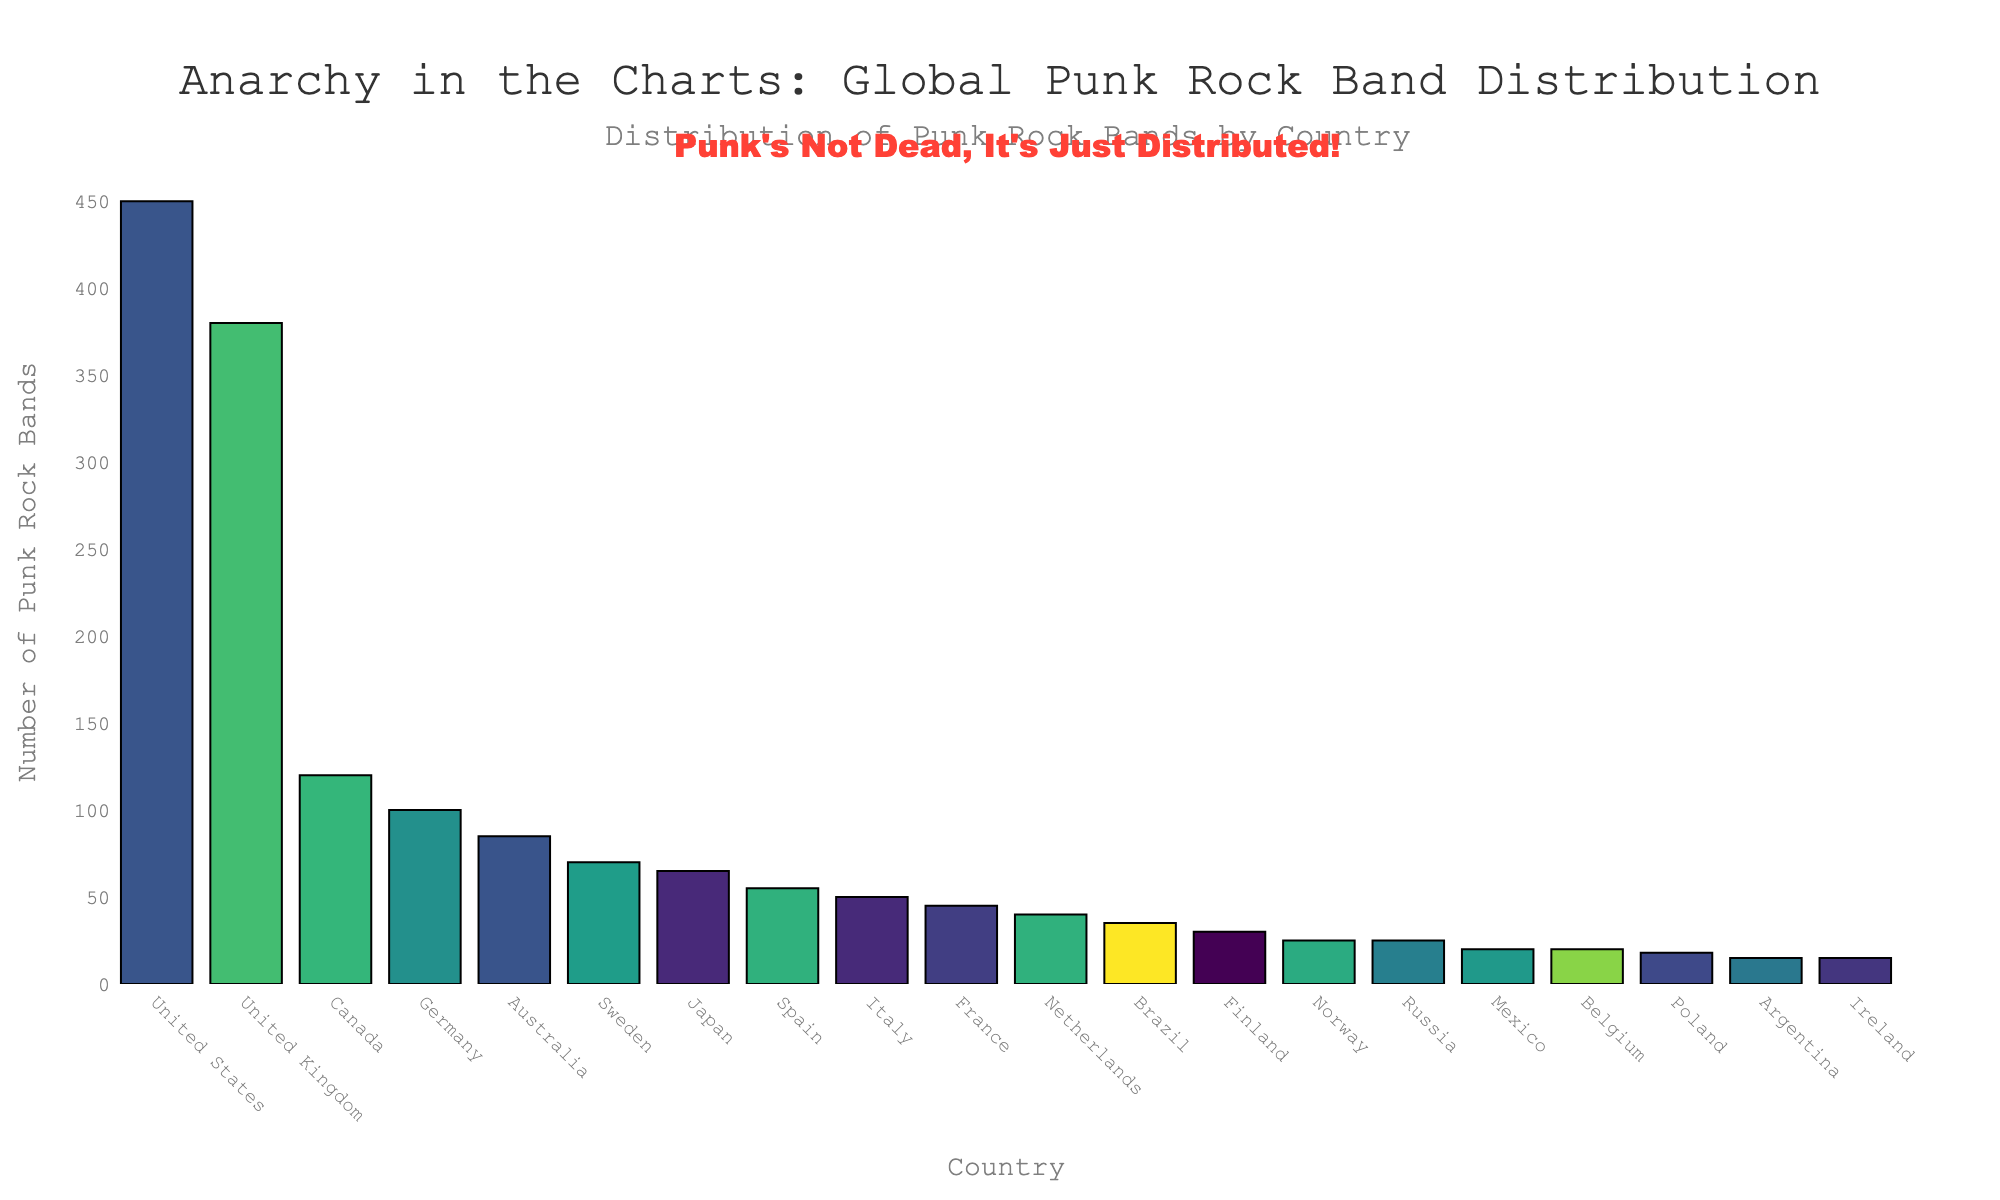What's the total number of punk rock bands from the top three countries? Add the number of bands from the United States, United Kingdom, and Canada (450 + 380 + 120).
Answer: 950 Which country has the second highest number of punk rock bands? Identify the second tallest bar in the chart, which corresponds to the United Kingdom.
Answer: United Kingdom How many more punk rock bands are there in Australia compared to Japan? Subtract the number of bands in Japan from the number in Australia (85 - 65).
Answer: 20 What is the average number of punk rock bands in Germany, Australia, and Sweden? Sum the number of bands from Germany, Australia, and Sweden, then divide by 3 ((100 + 85 + 70) / 3).
Answer: 85 Which countries have an equal number of punk rock bands, according to the data? Identify bars of the same height, Norway and Russia (both with 25 bands), and Mexico and Belgium (both with 20 bands).
Answer: Norway, Russia; Mexico, Belgium What’s the difference in the number of punk rock bands between the country with the most bands and the country with the fewest bands? Subtract the number of bands in Argentina (the fewest with 15) from the number in the United States (the most with 450).
Answer: 435 Which country is just below France in the number of punk rock bands? Look at the bar representing France and identify the next shortest bar, which corresponds to the Netherlands.
Answer: Netherlands What is the combined total number of punk rock bands in Scandinavian countries (Sweden, Finland, and Norway)? Sum the number of bands from Sweden, Finland, and Norway (70 + 30 + 25).
Answer: 125 How many countries have more than 50 punk rock bands? Count the countries with bands greater than 50: United States, United Kingdom, Canada, Germany, Australia, Sweden, and Japan (7 countries).
Answer: 7 Which country has the closest number of punk rock bands to the global median? The median rank is the 10th (France), with 45 bands (sorted data).
Answer: France 